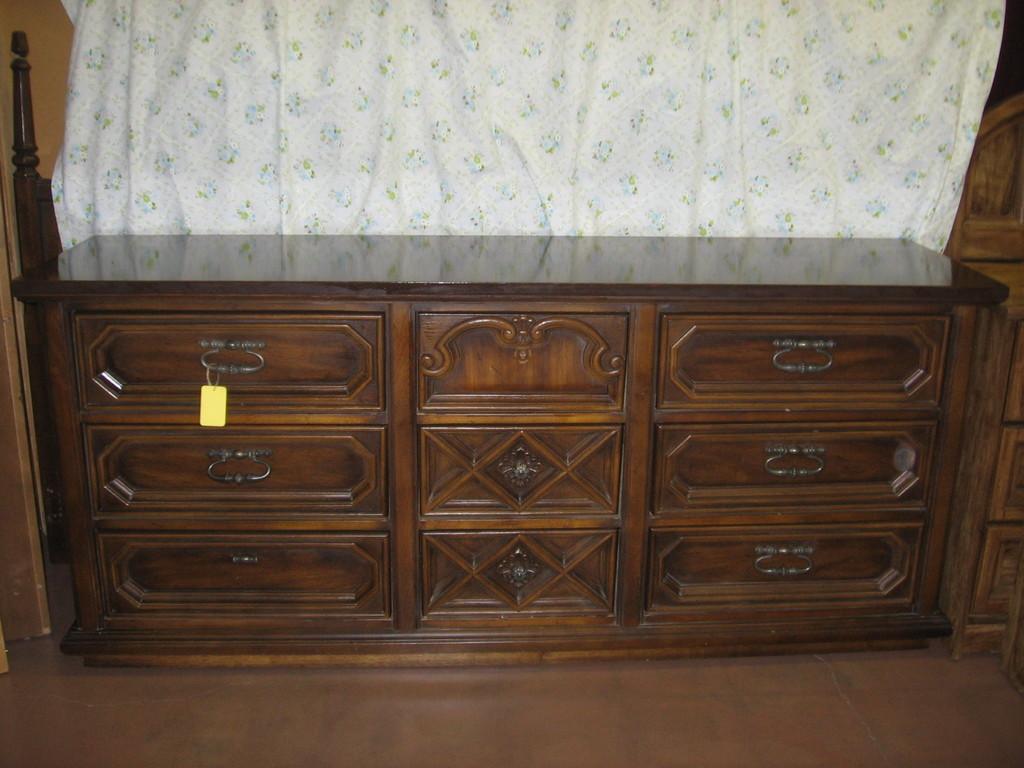Could you give a brief overview of what you see in this image? In this picture we can see drawers and a curtain. 